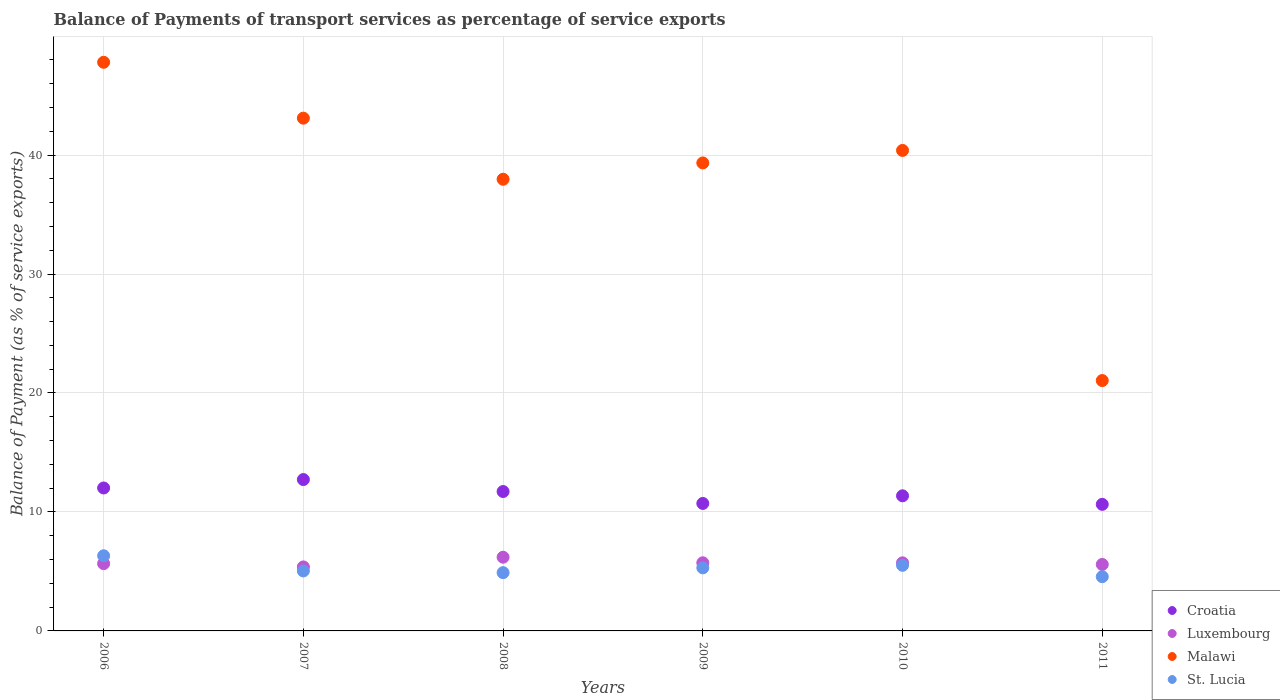How many different coloured dotlines are there?
Your response must be concise. 4. What is the balance of payments of transport services in Malawi in 2008?
Make the answer very short. 37.96. Across all years, what is the maximum balance of payments of transport services in St. Lucia?
Offer a very short reply. 6.32. Across all years, what is the minimum balance of payments of transport services in Luxembourg?
Make the answer very short. 5.38. What is the total balance of payments of transport services in Luxembourg in the graph?
Offer a terse response. 34.27. What is the difference between the balance of payments of transport services in St. Lucia in 2007 and that in 2008?
Provide a short and direct response. 0.14. What is the difference between the balance of payments of transport services in Malawi in 2011 and the balance of payments of transport services in Luxembourg in 2010?
Provide a succinct answer. 15.32. What is the average balance of payments of transport services in Luxembourg per year?
Your answer should be compact. 5.71. In the year 2011, what is the difference between the balance of payments of transport services in Croatia and balance of payments of transport services in Luxembourg?
Your response must be concise. 5.05. In how many years, is the balance of payments of transport services in Luxembourg greater than 46 %?
Your answer should be compact. 0. What is the ratio of the balance of payments of transport services in Luxembourg in 2008 to that in 2010?
Provide a succinct answer. 1.08. What is the difference between the highest and the second highest balance of payments of transport services in St. Lucia?
Give a very brief answer. 0.8. What is the difference between the highest and the lowest balance of payments of transport services in Malawi?
Your answer should be compact. 26.75. Is it the case that in every year, the sum of the balance of payments of transport services in Malawi and balance of payments of transport services in Croatia  is greater than the sum of balance of payments of transport services in St. Lucia and balance of payments of transport services in Luxembourg?
Keep it short and to the point. Yes. Is it the case that in every year, the sum of the balance of payments of transport services in St. Lucia and balance of payments of transport services in Luxembourg  is greater than the balance of payments of transport services in Malawi?
Provide a succinct answer. No. Is the balance of payments of transport services in Croatia strictly greater than the balance of payments of transport services in Malawi over the years?
Your response must be concise. No. How many years are there in the graph?
Offer a terse response. 6. What is the difference between two consecutive major ticks on the Y-axis?
Your answer should be compact. 10. Does the graph contain grids?
Offer a very short reply. Yes. Where does the legend appear in the graph?
Your answer should be very brief. Bottom right. What is the title of the graph?
Make the answer very short. Balance of Payments of transport services as percentage of service exports. What is the label or title of the X-axis?
Ensure brevity in your answer.  Years. What is the label or title of the Y-axis?
Your response must be concise. Balance of Payment (as % of service exports). What is the Balance of Payment (as % of service exports) of Croatia in 2006?
Offer a terse response. 12.01. What is the Balance of Payment (as % of service exports) of Luxembourg in 2006?
Your response must be concise. 5.66. What is the Balance of Payment (as % of service exports) of Malawi in 2006?
Your answer should be very brief. 47.8. What is the Balance of Payment (as % of service exports) of St. Lucia in 2006?
Provide a succinct answer. 6.32. What is the Balance of Payment (as % of service exports) in Croatia in 2007?
Make the answer very short. 12.72. What is the Balance of Payment (as % of service exports) of Luxembourg in 2007?
Keep it short and to the point. 5.38. What is the Balance of Payment (as % of service exports) in Malawi in 2007?
Ensure brevity in your answer.  43.1. What is the Balance of Payment (as % of service exports) of St. Lucia in 2007?
Your answer should be very brief. 5.04. What is the Balance of Payment (as % of service exports) in Croatia in 2008?
Your answer should be compact. 11.72. What is the Balance of Payment (as % of service exports) of Luxembourg in 2008?
Provide a short and direct response. 6.2. What is the Balance of Payment (as % of service exports) in Malawi in 2008?
Offer a terse response. 37.96. What is the Balance of Payment (as % of service exports) in St. Lucia in 2008?
Keep it short and to the point. 4.9. What is the Balance of Payment (as % of service exports) in Croatia in 2009?
Make the answer very short. 10.71. What is the Balance of Payment (as % of service exports) in Luxembourg in 2009?
Offer a very short reply. 5.73. What is the Balance of Payment (as % of service exports) in Malawi in 2009?
Provide a succinct answer. 39.33. What is the Balance of Payment (as % of service exports) of St. Lucia in 2009?
Offer a very short reply. 5.3. What is the Balance of Payment (as % of service exports) of Croatia in 2010?
Your response must be concise. 11.36. What is the Balance of Payment (as % of service exports) of Luxembourg in 2010?
Offer a very short reply. 5.72. What is the Balance of Payment (as % of service exports) in Malawi in 2010?
Provide a short and direct response. 40.39. What is the Balance of Payment (as % of service exports) in St. Lucia in 2010?
Provide a short and direct response. 5.51. What is the Balance of Payment (as % of service exports) in Croatia in 2011?
Your answer should be compact. 10.64. What is the Balance of Payment (as % of service exports) in Luxembourg in 2011?
Offer a very short reply. 5.59. What is the Balance of Payment (as % of service exports) in Malawi in 2011?
Your response must be concise. 21.05. What is the Balance of Payment (as % of service exports) of St. Lucia in 2011?
Provide a succinct answer. 4.56. Across all years, what is the maximum Balance of Payment (as % of service exports) of Croatia?
Offer a terse response. 12.72. Across all years, what is the maximum Balance of Payment (as % of service exports) of Luxembourg?
Your answer should be very brief. 6.2. Across all years, what is the maximum Balance of Payment (as % of service exports) in Malawi?
Your answer should be compact. 47.8. Across all years, what is the maximum Balance of Payment (as % of service exports) in St. Lucia?
Your answer should be very brief. 6.32. Across all years, what is the minimum Balance of Payment (as % of service exports) of Croatia?
Ensure brevity in your answer.  10.64. Across all years, what is the minimum Balance of Payment (as % of service exports) of Luxembourg?
Ensure brevity in your answer.  5.38. Across all years, what is the minimum Balance of Payment (as % of service exports) of Malawi?
Provide a succinct answer. 21.05. Across all years, what is the minimum Balance of Payment (as % of service exports) of St. Lucia?
Keep it short and to the point. 4.56. What is the total Balance of Payment (as % of service exports) of Croatia in the graph?
Your response must be concise. 69.16. What is the total Balance of Payment (as % of service exports) in Luxembourg in the graph?
Make the answer very short. 34.27. What is the total Balance of Payment (as % of service exports) of Malawi in the graph?
Ensure brevity in your answer.  229.63. What is the total Balance of Payment (as % of service exports) in St. Lucia in the graph?
Make the answer very short. 31.63. What is the difference between the Balance of Payment (as % of service exports) in Croatia in 2006 and that in 2007?
Give a very brief answer. -0.71. What is the difference between the Balance of Payment (as % of service exports) of Luxembourg in 2006 and that in 2007?
Your answer should be compact. 0.28. What is the difference between the Balance of Payment (as % of service exports) in Malawi in 2006 and that in 2007?
Your answer should be very brief. 4.7. What is the difference between the Balance of Payment (as % of service exports) of St. Lucia in 2006 and that in 2007?
Your answer should be compact. 1.28. What is the difference between the Balance of Payment (as % of service exports) in Croatia in 2006 and that in 2008?
Keep it short and to the point. 0.3. What is the difference between the Balance of Payment (as % of service exports) of Luxembourg in 2006 and that in 2008?
Offer a terse response. -0.54. What is the difference between the Balance of Payment (as % of service exports) in Malawi in 2006 and that in 2008?
Your answer should be compact. 9.83. What is the difference between the Balance of Payment (as % of service exports) in St. Lucia in 2006 and that in 2008?
Make the answer very short. 1.42. What is the difference between the Balance of Payment (as % of service exports) in Croatia in 2006 and that in 2009?
Keep it short and to the point. 1.3. What is the difference between the Balance of Payment (as % of service exports) in Luxembourg in 2006 and that in 2009?
Make the answer very short. -0.07. What is the difference between the Balance of Payment (as % of service exports) of Malawi in 2006 and that in 2009?
Offer a very short reply. 8.46. What is the difference between the Balance of Payment (as % of service exports) in St. Lucia in 2006 and that in 2009?
Your answer should be compact. 1.02. What is the difference between the Balance of Payment (as % of service exports) in Croatia in 2006 and that in 2010?
Provide a succinct answer. 0.66. What is the difference between the Balance of Payment (as % of service exports) of Luxembourg in 2006 and that in 2010?
Your response must be concise. -0.07. What is the difference between the Balance of Payment (as % of service exports) in Malawi in 2006 and that in 2010?
Provide a short and direct response. 7.41. What is the difference between the Balance of Payment (as % of service exports) in St. Lucia in 2006 and that in 2010?
Make the answer very short. 0.8. What is the difference between the Balance of Payment (as % of service exports) in Croatia in 2006 and that in 2011?
Your answer should be very brief. 1.38. What is the difference between the Balance of Payment (as % of service exports) in Luxembourg in 2006 and that in 2011?
Make the answer very short. 0.07. What is the difference between the Balance of Payment (as % of service exports) of Malawi in 2006 and that in 2011?
Provide a succinct answer. 26.75. What is the difference between the Balance of Payment (as % of service exports) in St. Lucia in 2006 and that in 2011?
Offer a terse response. 1.76. What is the difference between the Balance of Payment (as % of service exports) in Croatia in 2007 and that in 2008?
Your response must be concise. 1.01. What is the difference between the Balance of Payment (as % of service exports) of Luxembourg in 2007 and that in 2008?
Your answer should be very brief. -0.82. What is the difference between the Balance of Payment (as % of service exports) in Malawi in 2007 and that in 2008?
Ensure brevity in your answer.  5.14. What is the difference between the Balance of Payment (as % of service exports) in St. Lucia in 2007 and that in 2008?
Offer a terse response. 0.14. What is the difference between the Balance of Payment (as % of service exports) of Croatia in 2007 and that in 2009?
Give a very brief answer. 2.01. What is the difference between the Balance of Payment (as % of service exports) of Luxembourg in 2007 and that in 2009?
Make the answer very short. -0.35. What is the difference between the Balance of Payment (as % of service exports) in Malawi in 2007 and that in 2009?
Your answer should be compact. 3.76. What is the difference between the Balance of Payment (as % of service exports) in St. Lucia in 2007 and that in 2009?
Ensure brevity in your answer.  -0.26. What is the difference between the Balance of Payment (as % of service exports) in Croatia in 2007 and that in 2010?
Provide a succinct answer. 1.37. What is the difference between the Balance of Payment (as % of service exports) in Luxembourg in 2007 and that in 2010?
Offer a very short reply. -0.34. What is the difference between the Balance of Payment (as % of service exports) of Malawi in 2007 and that in 2010?
Offer a very short reply. 2.71. What is the difference between the Balance of Payment (as % of service exports) in St. Lucia in 2007 and that in 2010?
Give a very brief answer. -0.47. What is the difference between the Balance of Payment (as % of service exports) of Croatia in 2007 and that in 2011?
Give a very brief answer. 2.08. What is the difference between the Balance of Payment (as % of service exports) of Luxembourg in 2007 and that in 2011?
Your answer should be very brief. -0.21. What is the difference between the Balance of Payment (as % of service exports) of Malawi in 2007 and that in 2011?
Provide a succinct answer. 22.05. What is the difference between the Balance of Payment (as % of service exports) in St. Lucia in 2007 and that in 2011?
Keep it short and to the point. 0.48. What is the difference between the Balance of Payment (as % of service exports) of Croatia in 2008 and that in 2009?
Ensure brevity in your answer.  1. What is the difference between the Balance of Payment (as % of service exports) in Luxembourg in 2008 and that in 2009?
Give a very brief answer. 0.47. What is the difference between the Balance of Payment (as % of service exports) of Malawi in 2008 and that in 2009?
Your answer should be very brief. -1.37. What is the difference between the Balance of Payment (as % of service exports) of St. Lucia in 2008 and that in 2009?
Make the answer very short. -0.4. What is the difference between the Balance of Payment (as % of service exports) in Croatia in 2008 and that in 2010?
Provide a succinct answer. 0.36. What is the difference between the Balance of Payment (as % of service exports) of Luxembourg in 2008 and that in 2010?
Offer a very short reply. 0.47. What is the difference between the Balance of Payment (as % of service exports) of Malawi in 2008 and that in 2010?
Provide a short and direct response. -2.42. What is the difference between the Balance of Payment (as % of service exports) of St. Lucia in 2008 and that in 2010?
Your answer should be very brief. -0.61. What is the difference between the Balance of Payment (as % of service exports) of Croatia in 2008 and that in 2011?
Provide a succinct answer. 1.08. What is the difference between the Balance of Payment (as % of service exports) in Luxembourg in 2008 and that in 2011?
Your answer should be compact. 0.61. What is the difference between the Balance of Payment (as % of service exports) in Malawi in 2008 and that in 2011?
Your answer should be very brief. 16.92. What is the difference between the Balance of Payment (as % of service exports) of St. Lucia in 2008 and that in 2011?
Your response must be concise. 0.34. What is the difference between the Balance of Payment (as % of service exports) in Croatia in 2009 and that in 2010?
Offer a very short reply. -0.64. What is the difference between the Balance of Payment (as % of service exports) in Luxembourg in 2009 and that in 2010?
Ensure brevity in your answer.  0. What is the difference between the Balance of Payment (as % of service exports) in Malawi in 2009 and that in 2010?
Offer a terse response. -1.05. What is the difference between the Balance of Payment (as % of service exports) in St. Lucia in 2009 and that in 2010?
Your answer should be very brief. -0.21. What is the difference between the Balance of Payment (as % of service exports) of Croatia in 2009 and that in 2011?
Provide a succinct answer. 0.08. What is the difference between the Balance of Payment (as % of service exports) of Luxembourg in 2009 and that in 2011?
Your answer should be very brief. 0.14. What is the difference between the Balance of Payment (as % of service exports) of Malawi in 2009 and that in 2011?
Provide a short and direct response. 18.29. What is the difference between the Balance of Payment (as % of service exports) of St. Lucia in 2009 and that in 2011?
Provide a short and direct response. 0.74. What is the difference between the Balance of Payment (as % of service exports) in Croatia in 2010 and that in 2011?
Offer a very short reply. 0.72. What is the difference between the Balance of Payment (as % of service exports) of Luxembourg in 2010 and that in 2011?
Keep it short and to the point. 0.13. What is the difference between the Balance of Payment (as % of service exports) in Malawi in 2010 and that in 2011?
Offer a terse response. 19.34. What is the difference between the Balance of Payment (as % of service exports) in St. Lucia in 2010 and that in 2011?
Your answer should be compact. 0.95. What is the difference between the Balance of Payment (as % of service exports) in Croatia in 2006 and the Balance of Payment (as % of service exports) in Luxembourg in 2007?
Keep it short and to the point. 6.64. What is the difference between the Balance of Payment (as % of service exports) in Croatia in 2006 and the Balance of Payment (as % of service exports) in Malawi in 2007?
Provide a succinct answer. -31.08. What is the difference between the Balance of Payment (as % of service exports) in Croatia in 2006 and the Balance of Payment (as % of service exports) in St. Lucia in 2007?
Your answer should be compact. 6.97. What is the difference between the Balance of Payment (as % of service exports) in Luxembourg in 2006 and the Balance of Payment (as % of service exports) in Malawi in 2007?
Your response must be concise. -37.44. What is the difference between the Balance of Payment (as % of service exports) of Luxembourg in 2006 and the Balance of Payment (as % of service exports) of St. Lucia in 2007?
Ensure brevity in your answer.  0.61. What is the difference between the Balance of Payment (as % of service exports) of Malawi in 2006 and the Balance of Payment (as % of service exports) of St. Lucia in 2007?
Your response must be concise. 42.75. What is the difference between the Balance of Payment (as % of service exports) in Croatia in 2006 and the Balance of Payment (as % of service exports) in Luxembourg in 2008?
Your answer should be very brief. 5.82. What is the difference between the Balance of Payment (as % of service exports) in Croatia in 2006 and the Balance of Payment (as % of service exports) in Malawi in 2008?
Your response must be concise. -25.95. What is the difference between the Balance of Payment (as % of service exports) of Croatia in 2006 and the Balance of Payment (as % of service exports) of St. Lucia in 2008?
Keep it short and to the point. 7.12. What is the difference between the Balance of Payment (as % of service exports) of Luxembourg in 2006 and the Balance of Payment (as % of service exports) of Malawi in 2008?
Give a very brief answer. -32.31. What is the difference between the Balance of Payment (as % of service exports) of Luxembourg in 2006 and the Balance of Payment (as % of service exports) of St. Lucia in 2008?
Provide a short and direct response. 0.76. What is the difference between the Balance of Payment (as % of service exports) in Malawi in 2006 and the Balance of Payment (as % of service exports) in St. Lucia in 2008?
Make the answer very short. 42.9. What is the difference between the Balance of Payment (as % of service exports) in Croatia in 2006 and the Balance of Payment (as % of service exports) in Luxembourg in 2009?
Ensure brevity in your answer.  6.29. What is the difference between the Balance of Payment (as % of service exports) of Croatia in 2006 and the Balance of Payment (as % of service exports) of Malawi in 2009?
Offer a terse response. -27.32. What is the difference between the Balance of Payment (as % of service exports) in Croatia in 2006 and the Balance of Payment (as % of service exports) in St. Lucia in 2009?
Your answer should be very brief. 6.71. What is the difference between the Balance of Payment (as % of service exports) in Luxembourg in 2006 and the Balance of Payment (as % of service exports) in Malawi in 2009?
Provide a succinct answer. -33.68. What is the difference between the Balance of Payment (as % of service exports) in Luxembourg in 2006 and the Balance of Payment (as % of service exports) in St. Lucia in 2009?
Your answer should be compact. 0.35. What is the difference between the Balance of Payment (as % of service exports) of Malawi in 2006 and the Balance of Payment (as % of service exports) of St. Lucia in 2009?
Provide a succinct answer. 42.49. What is the difference between the Balance of Payment (as % of service exports) of Croatia in 2006 and the Balance of Payment (as % of service exports) of Luxembourg in 2010?
Offer a terse response. 6.29. What is the difference between the Balance of Payment (as % of service exports) of Croatia in 2006 and the Balance of Payment (as % of service exports) of Malawi in 2010?
Provide a succinct answer. -28.37. What is the difference between the Balance of Payment (as % of service exports) of Croatia in 2006 and the Balance of Payment (as % of service exports) of St. Lucia in 2010?
Offer a very short reply. 6.5. What is the difference between the Balance of Payment (as % of service exports) of Luxembourg in 2006 and the Balance of Payment (as % of service exports) of Malawi in 2010?
Offer a very short reply. -34.73. What is the difference between the Balance of Payment (as % of service exports) in Luxembourg in 2006 and the Balance of Payment (as % of service exports) in St. Lucia in 2010?
Your answer should be compact. 0.14. What is the difference between the Balance of Payment (as % of service exports) of Malawi in 2006 and the Balance of Payment (as % of service exports) of St. Lucia in 2010?
Make the answer very short. 42.28. What is the difference between the Balance of Payment (as % of service exports) in Croatia in 2006 and the Balance of Payment (as % of service exports) in Luxembourg in 2011?
Provide a succinct answer. 6.43. What is the difference between the Balance of Payment (as % of service exports) in Croatia in 2006 and the Balance of Payment (as % of service exports) in Malawi in 2011?
Give a very brief answer. -9.03. What is the difference between the Balance of Payment (as % of service exports) of Croatia in 2006 and the Balance of Payment (as % of service exports) of St. Lucia in 2011?
Keep it short and to the point. 7.45. What is the difference between the Balance of Payment (as % of service exports) of Luxembourg in 2006 and the Balance of Payment (as % of service exports) of Malawi in 2011?
Your answer should be compact. -15.39. What is the difference between the Balance of Payment (as % of service exports) of Luxembourg in 2006 and the Balance of Payment (as % of service exports) of St. Lucia in 2011?
Your answer should be compact. 1.1. What is the difference between the Balance of Payment (as % of service exports) in Malawi in 2006 and the Balance of Payment (as % of service exports) in St. Lucia in 2011?
Your response must be concise. 43.23. What is the difference between the Balance of Payment (as % of service exports) in Croatia in 2007 and the Balance of Payment (as % of service exports) in Luxembourg in 2008?
Provide a short and direct response. 6.53. What is the difference between the Balance of Payment (as % of service exports) in Croatia in 2007 and the Balance of Payment (as % of service exports) in Malawi in 2008?
Keep it short and to the point. -25.24. What is the difference between the Balance of Payment (as % of service exports) of Croatia in 2007 and the Balance of Payment (as % of service exports) of St. Lucia in 2008?
Ensure brevity in your answer.  7.82. What is the difference between the Balance of Payment (as % of service exports) in Luxembourg in 2007 and the Balance of Payment (as % of service exports) in Malawi in 2008?
Your answer should be compact. -32.58. What is the difference between the Balance of Payment (as % of service exports) of Luxembourg in 2007 and the Balance of Payment (as % of service exports) of St. Lucia in 2008?
Keep it short and to the point. 0.48. What is the difference between the Balance of Payment (as % of service exports) in Malawi in 2007 and the Balance of Payment (as % of service exports) in St. Lucia in 2008?
Give a very brief answer. 38.2. What is the difference between the Balance of Payment (as % of service exports) in Croatia in 2007 and the Balance of Payment (as % of service exports) in Luxembourg in 2009?
Give a very brief answer. 7. What is the difference between the Balance of Payment (as % of service exports) of Croatia in 2007 and the Balance of Payment (as % of service exports) of Malawi in 2009?
Provide a succinct answer. -26.61. What is the difference between the Balance of Payment (as % of service exports) in Croatia in 2007 and the Balance of Payment (as % of service exports) in St. Lucia in 2009?
Offer a very short reply. 7.42. What is the difference between the Balance of Payment (as % of service exports) of Luxembourg in 2007 and the Balance of Payment (as % of service exports) of Malawi in 2009?
Your answer should be very brief. -33.96. What is the difference between the Balance of Payment (as % of service exports) in Luxembourg in 2007 and the Balance of Payment (as % of service exports) in St. Lucia in 2009?
Provide a succinct answer. 0.08. What is the difference between the Balance of Payment (as % of service exports) in Malawi in 2007 and the Balance of Payment (as % of service exports) in St. Lucia in 2009?
Give a very brief answer. 37.8. What is the difference between the Balance of Payment (as % of service exports) in Croatia in 2007 and the Balance of Payment (as % of service exports) in Luxembourg in 2010?
Provide a succinct answer. 7. What is the difference between the Balance of Payment (as % of service exports) in Croatia in 2007 and the Balance of Payment (as % of service exports) in Malawi in 2010?
Provide a short and direct response. -27.67. What is the difference between the Balance of Payment (as % of service exports) of Croatia in 2007 and the Balance of Payment (as % of service exports) of St. Lucia in 2010?
Make the answer very short. 7.21. What is the difference between the Balance of Payment (as % of service exports) in Luxembourg in 2007 and the Balance of Payment (as % of service exports) in Malawi in 2010?
Offer a very short reply. -35.01. What is the difference between the Balance of Payment (as % of service exports) of Luxembourg in 2007 and the Balance of Payment (as % of service exports) of St. Lucia in 2010?
Offer a terse response. -0.13. What is the difference between the Balance of Payment (as % of service exports) of Malawi in 2007 and the Balance of Payment (as % of service exports) of St. Lucia in 2010?
Your response must be concise. 37.59. What is the difference between the Balance of Payment (as % of service exports) in Croatia in 2007 and the Balance of Payment (as % of service exports) in Luxembourg in 2011?
Give a very brief answer. 7.13. What is the difference between the Balance of Payment (as % of service exports) of Croatia in 2007 and the Balance of Payment (as % of service exports) of Malawi in 2011?
Give a very brief answer. -8.32. What is the difference between the Balance of Payment (as % of service exports) in Croatia in 2007 and the Balance of Payment (as % of service exports) in St. Lucia in 2011?
Offer a very short reply. 8.16. What is the difference between the Balance of Payment (as % of service exports) of Luxembourg in 2007 and the Balance of Payment (as % of service exports) of Malawi in 2011?
Keep it short and to the point. -15.67. What is the difference between the Balance of Payment (as % of service exports) of Luxembourg in 2007 and the Balance of Payment (as % of service exports) of St. Lucia in 2011?
Give a very brief answer. 0.82. What is the difference between the Balance of Payment (as % of service exports) of Malawi in 2007 and the Balance of Payment (as % of service exports) of St. Lucia in 2011?
Offer a terse response. 38.54. What is the difference between the Balance of Payment (as % of service exports) of Croatia in 2008 and the Balance of Payment (as % of service exports) of Luxembourg in 2009?
Ensure brevity in your answer.  5.99. What is the difference between the Balance of Payment (as % of service exports) in Croatia in 2008 and the Balance of Payment (as % of service exports) in Malawi in 2009?
Give a very brief answer. -27.62. What is the difference between the Balance of Payment (as % of service exports) of Croatia in 2008 and the Balance of Payment (as % of service exports) of St. Lucia in 2009?
Keep it short and to the point. 6.42. What is the difference between the Balance of Payment (as % of service exports) of Luxembourg in 2008 and the Balance of Payment (as % of service exports) of Malawi in 2009?
Offer a terse response. -33.14. What is the difference between the Balance of Payment (as % of service exports) of Luxembourg in 2008 and the Balance of Payment (as % of service exports) of St. Lucia in 2009?
Give a very brief answer. 0.89. What is the difference between the Balance of Payment (as % of service exports) in Malawi in 2008 and the Balance of Payment (as % of service exports) in St. Lucia in 2009?
Your answer should be compact. 32.66. What is the difference between the Balance of Payment (as % of service exports) of Croatia in 2008 and the Balance of Payment (as % of service exports) of Luxembourg in 2010?
Ensure brevity in your answer.  6. What is the difference between the Balance of Payment (as % of service exports) of Croatia in 2008 and the Balance of Payment (as % of service exports) of Malawi in 2010?
Make the answer very short. -28.67. What is the difference between the Balance of Payment (as % of service exports) in Croatia in 2008 and the Balance of Payment (as % of service exports) in St. Lucia in 2010?
Your response must be concise. 6.2. What is the difference between the Balance of Payment (as % of service exports) of Luxembourg in 2008 and the Balance of Payment (as % of service exports) of Malawi in 2010?
Your answer should be very brief. -34.19. What is the difference between the Balance of Payment (as % of service exports) of Luxembourg in 2008 and the Balance of Payment (as % of service exports) of St. Lucia in 2010?
Offer a terse response. 0.68. What is the difference between the Balance of Payment (as % of service exports) in Malawi in 2008 and the Balance of Payment (as % of service exports) in St. Lucia in 2010?
Provide a short and direct response. 32.45. What is the difference between the Balance of Payment (as % of service exports) of Croatia in 2008 and the Balance of Payment (as % of service exports) of Luxembourg in 2011?
Give a very brief answer. 6.13. What is the difference between the Balance of Payment (as % of service exports) of Croatia in 2008 and the Balance of Payment (as % of service exports) of Malawi in 2011?
Provide a short and direct response. -9.33. What is the difference between the Balance of Payment (as % of service exports) of Croatia in 2008 and the Balance of Payment (as % of service exports) of St. Lucia in 2011?
Your answer should be very brief. 7.16. What is the difference between the Balance of Payment (as % of service exports) of Luxembourg in 2008 and the Balance of Payment (as % of service exports) of Malawi in 2011?
Offer a very short reply. -14.85. What is the difference between the Balance of Payment (as % of service exports) of Luxembourg in 2008 and the Balance of Payment (as % of service exports) of St. Lucia in 2011?
Offer a very short reply. 1.64. What is the difference between the Balance of Payment (as % of service exports) in Malawi in 2008 and the Balance of Payment (as % of service exports) in St. Lucia in 2011?
Your answer should be compact. 33.4. What is the difference between the Balance of Payment (as % of service exports) in Croatia in 2009 and the Balance of Payment (as % of service exports) in Luxembourg in 2010?
Ensure brevity in your answer.  4.99. What is the difference between the Balance of Payment (as % of service exports) in Croatia in 2009 and the Balance of Payment (as % of service exports) in Malawi in 2010?
Provide a succinct answer. -29.67. What is the difference between the Balance of Payment (as % of service exports) in Croatia in 2009 and the Balance of Payment (as % of service exports) in St. Lucia in 2010?
Provide a succinct answer. 5.2. What is the difference between the Balance of Payment (as % of service exports) of Luxembourg in 2009 and the Balance of Payment (as % of service exports) of Malawi in 2010?
Make the answer very short. -34.66. What is the difference between the Balance of Payment (as % of service exports) of Luxembourg in 2009 and the Balance of Payment (as % of service exports) of St. Lucia in 2010?
Give a very brief answer. 0.21. What is the difference between the Balance of Payment (as % of service exports) of Malawi in 2009 and the Balance of Payment (as % of service exports) of St. Lucia in 2010?
Keep it short and to the point. 33.82. What is the difference between the Balance of Payment (as % of service exports) in Croatia in 2009 and the Balance of Payment (as % of service exports) in Luxembourg in 2011?
Provide a succinct answer. 5.13. What is the difference between the Balance of Payment (as % of service exports) of Croatia in 2009 and the Balance of Payment (as % of service exports) of Malawi in 2011?
Your response must be concise. -10.33. What is the difference between the Balance of Payment (as % of service exports) of Croatia in 2009 and the Balance of Payment (as % of service exports) of St. Lucia in 2011?
Keep it short and to the point. 6.15. What is the difference between the Balance of Payment (as % of service exports) of Luxembourg in 2009 and the Balance of Payment (as % of service exports) of Malawi in 2011?
Your answer should be very brief. -15.32. What is the difference between the Balance of Payment (as % of service exports) of Luxembourg in 2009 and the Balance of Payment (as % of service exports) of St. Lucia in 2011?
Keep it short and to the point. 1.17. What is the difference between the Balance of Payment (as % of service exports) in Malawi in 2009 and the Balance of Payment (as % of service exports) in St. Lucia in 2011?
Provide a short and direct response. 34.77. What is the difference between the Balance of Payment (as % of service exports) in Croatia in 2010 and the Balance of Payment (as % of service exports) in Luxembourg in 2011?
Keep it short and to the point. 5.77. What is the difference between the Balance of Payment (as % of service exports) of Croatia in 2010 and the Balance of Payment (as % of service exports) of Malawi in 2011?
Provide a succinct answer. -9.69. What is the difference between the Balance of Payment (as % of service exports) in Croatia in 2010 and the Balance of Payment (as % of service exports) in St. Lucia in 2011?
Provide a succinct answer. 6.8. What is the difference between the Balance of Payment (as % of service exports) in Luxembourg in 2010 and the Balance of Payment (as % of service exports) in Malawi in 2011?
Provide a succinct answer. -15.32. What is the difference between the Balance of Payment (as % of service exports) of Luxembourg in 2010 and the Balance of Payment (as % of service exports) of St. Lucia in 2011?
Keep it short and to the point. 1.16. What is the difference between the Balance of Payment (as % of service exports) in Malawi in 2010 and the Balance of Payment (as % of service exports) in St. Lucia in 2011?
Offer a terse response. 35.83. What is the average Balance of Payment (as % of service exports) of Croatia per year?
Offer a terse response. 11.53. What is the average Balance of Payment (as % of service exports) in Luxembourg per year?
Your response must be concise. 5.71. What is the average Balance of Payment (as % of service exports) of Malawi per year?
Your response must be concise. 38.27. What is the average Balance of Payment (as % of service exports) in St. Lucia per year?
Ensure brevity in your answer.  5.27. In the year 2006, what is the difference between the Balance of Payment (as % of service exports) of Croatia and Balance of Payment (as % of service exports) of Luxembourg?
Ensure brevity in your answer.  6.36. In the year 2006, what is the difference between the Balance of Payment (as % of service exports) of Croatia and Balance of Payment (as % of service exports) of Malawi?
Keep it short and to the point. -35.78. In the year 2006, what is the difference between the Balance of Payment (as % of service exports) in Croatia and Balance of Payment (as % of service exports) in St. Lucia?
Provide a short and direct response. 5.7. In the year 2006, what is the difference between the Balance of Payment (as % of service exports) of Luxembourg and Balance of Payment (as % of service exports) of Malawi?
Keep it short and to the point. -42.14. In the year 2006, what is the difference between the Balance of Payment (as % of service exports) in Luxembourg and Balance of Payment (as % of service exports) in St. Lucia?
Your answer should be compact. -0.66. In the year 2006, what is the difference between the Balance of Payment (as % of service exports) of Malawi and Balance of Payment (as % of service exports) of St. Lucia?
Offer a terse response. 41.48. In the year 2007, what is the difference between the Balance of Payment (as % of service exports) in Croatia and Balance of Payment (as % of service exports) in Luxembourg?
Ensure brevity in your answer.  7.34. In the year 2007, what is the difference between the Balance of Payment (as % of service exports) in Croatia and Balance of Payment (as % of service exports) in Malawi?
Your answer should be very brief. -30.38. In the year 2007, what is the difference between the Balance of Payment (as % of service exports) in Croatia and Balance of Payment (as % of service exports) in St. Lucia?
Give a very brief answer. 7.68. In the year 2007, what is the difference between the Balance of Payment (as % of service exports) in Luxembourg and Balance of Payment (as % of service exports) in Malawi?
Provide a succinct answer. -37.72. In the year 2007, what is the difference between the Balance of Payment (as % of service exports) of Luxembourg and Balance of Payment (as % of service exports) of St. Lucia?
Keep it short and to the point. 0.34. In the year 2007, what is the difference between the Balance of Payment (as % of service exports) of Malawi and Balance of Payment (as % of service exports) of St. Lucia?
Ensure brevity in your answer.  38.06. In the year 2008, what is the difference between the Balance of Payment (as % of service exports) in Croatia and Balance of Payment (as % of service exports) in Luxembourg?
Your response must be concise. 5.52. In the year 2008, what is the difference between the Balance of Payment (as % of service exports) of Croatia and Balance of Payment (as % of service exports) of Malawi?
Your answer should be very brief. -26.25. In the year 2008, what is the difference between the Balance of Payment (as % of service exports) of Croatia and Balance of Payment (as % of service exports) of St. Lucia?
Make the answer very short. 6.82. In the year 2008, what is the difference between the Balance of Payment (as % of service exports) of Luxembourg and Balance of Payment (as % of service exports) of Malawi?
Your answer should be compact. -31.77. In the year 2008, what is the difference between the Balance of Payment (as % of service exports) of Luxembourg and Balance of Payment (as % of service exports) of St. Lucia?
Your answer should be very brief. 1.3. In the year 2008, what is the difference between the Balance of Payment (as % of service exports) of Malawi and Balance of Payment (as % of service exports) of St. Lucia?
Keep it short and to the point. 33.07. In the year 2009, what is the difference between the Balance of Payment (as % of service exports) of Croatia and Balance of Payment (as % of service exports) of Luxembourg?
Your answer should be very brief. 4.99. In the year 2009, what is the difference between the Balance of Payment (as % of service exports) in Croatia and Balance of Payment (as % of service exports) in Malawi?
Your answer should be very brief. -28.62. In the year 2009, what is the difference between the Balance of Payment (as % of service exports) in Croatia and Balance of Payment (as % of service exports) in St. Lucia?
Offer a very short reply. 5.41. In the year 2009, what is the difference between the Balance of Payment (as % of service exports) of Luxembourg and Balance of Payment (as % of service exports) of Malawi?
Offer a terse response. -33.61. In the year 2009, what is the difference between the Balance of Payment (as % of service exports) of Luxembourg and Balance of Payment (as % of service exports) of St. Lucia?
Offer a very short reply. 0.42. In the year 2009, what is the difference between the Balance of Payment (as % of service exports) of Malawi and Balance of Payment (as % of service exports) of St. Lucia?
Your response must be concise. 34.03. In the year 2010, what is the difference between the Balance of Payment (as % of service exports) of Croatia and Balance of Payment (as % of service exports) of Luxembourg?
Ensure brevity in your answer.  5.63. In the year 2010, what is the difference between the Balance of Payment (as % of service exports) in Croatia and Balance of Payment (as % of service exports) in Malawi?
Your answer should be very brief. -29.03. In the year 2010, what is the difference between the Balance of Payment (as % of service exports) in Croatia and Balance of Payment (as % of service exports) in St. Lucia?
Your answer should be compact. 5.84. In the year 2010, what is the difference between the Balance of Payment (as % of service exports) of Luxembourg and Balance of Payment (as % of service exports) of Malawi?
Your answer should be very brief. -34.67. In the year 2010, what is the difference between the Balance of Payment (as % of service exports) of Luxembourg and Balance of Payment (as % of service exports) of St. Lucia?
Make the answer very short. 0.21. In the year 2010, what is the difference between the Balance of Payment (as % of service exports) of Malawi and Balance of Payment (as % of service exports) of St. Lucia?
Give a very brief answer. 34.87. In the year 2011, what is the difference between the Balance of Payment (as % of service exports) of Croatia and Balance of Payment (as % of service exports) of Luxembourg?
Provide a succinct answer. 5.05. In the year 2011, what is the difference between the Balance of Payment (as % of service exports) of Croatia and Balance of Payment (as % of service exports) of Malawi?
Provide a short and direct response. -10.41. In the year 2011, what is the difference between the Balance of Payment (as % of service exports) in Croatia and Balance of Payment (as % of service exports) in St. Lucia?
Offer a terse response. 6.08. In the year 2011, what is the difference between the Balance of Payment (as % of service exports) in Luxembourg and Balance of Payment (as % of service exports) in Malawi?
Provide a succinct answer. -15.46. In the year 2011, what is the difference between the Balance of Payment (as % of service exports) of Luxembourg and Balance of Payment (as % of service exports) of St. Lucia?
Offer a terse response. 1.03. In the year 2011, what is the difference between the Balance of Payment (as % of service exports) of Malawi and Balance of Payment (as % of service exports) of St. Lucia?
Your answer should be very brief. 16.48. What is the ratio of the Balance of Payment (as % of service exports) of Croatia in 2006 to that in 2007?
Offer a very short reply. 0.94. What is the ratio of the Balance of Payment (as % of service exports) in Luxembourg in 2006 to that in 2007?
Give a very brief answer. 1.05. What is the ratio of the Balance of Payment (as % of service exports) in Malawi in 2006 to that in 2007?
Keep it short and to the point. 1.11. What is the ratio of the Balance of Payment (as % of service exports) in St. Lucia in 2006 to that in 2007?
Your answer should be compact. 1.25. What is the ratio of the Balance of Payment (as % of service exports) of Croatia in 2006 to that in 2008?
Your answer should be very brief. 1.03. What is the ratio of the Balance of Payment (as % of service exports) of Luxembourg in 2006 to that in 2008?
Your response must be concise. 0.91. What is the ratio of the Balance of Payment (as % of service exports) in Malawi in 2006 to that in 2008?
Your answer should be compact. 1.26. What is the ratio of the Balance of Payment (as % of service exports) in St. Lucia in 2006 to that in 2008?
Your answer should be compact. 1.29. What is the ratio of the Balance of Payment (as % of service exports) of Croatia in 2006 to that in 2009?
Make the answer very short. 1.12. What is the ratio of the Balance of Payment (as % of service exports) of Malawi in 2006 to that in 2009?
Offer a very short reply. 1.22. What is the ratio of the Balance of Payment (as % of service exports) in St. Lucia in 2006 to that in 2009?
Your response must be concise. 1.19. What is the ratio of the Balance of Payment (as % of service exports) of Croatia in 2006 to that in 2010?
Your answer should be very brief. 1.06. What is the ratio of the Balance of Payment (as % of service exports) in Luxembourg in 2006 to that in 2010?
Your answer should be compact. 0.99. What is the ratio of the Balance of Payment (as % of service exports) of Malawi in 2006 to that in 2010?
Keep it short and to the point. 1.18. What is the ratio of the Balance of Payment (as % of service exports) in St. Lucia in 2006 to that in 2010?
Your response must be concise. 1.15. What is the ratio of the Balance of Payment (as % of service exports) of Croatia in 2006 to that in 2011?
Keep it short and to the point. 1.13. What is the ratio of the Balance of Payment (as % of service exports) in Luxembourg in 2006 to that in 2011?
Ensure brevity in your answer.  1.01. What is the ratio of the Balance of Payment (as % of service exports) in Malawi in 2006 to that in 2011?
Your answer should be very brief. 2.27. What is the ratio of the Balance of Payment (as % of service exports) of St. Lucia in 2006 to that in 2011?
Give a very brief answer. 1.39. What is the ratio of the Balance of Payment (as % of service exports) in Croatia in 2007 to that in 2008?
Offer a terse response. 1.09. What is the ratio of the Balance of Payment (as % of service exports) of Luxembourg in 2007 to that in 2008?
Keep it short and to the point. 0.87. What is the ratio of the Balance of Payment (as % of service exports) of Malawi in 2007 to that in 2008?
Provide a short and direct response. 1.14. What is the ratio of the Balance of Payment (as % of service exports) of St. Lucia in 2007 to that in 2008?
Offer a very short reply. 1.03. What is the ratio of the Balance of Payment (as % of service exports) in Croatia in 2007 to that in 2009?
Your answer should be very brief. 1.19. What is the ratio of the Balance of Payment (as % of service exports) in Luxembourg in 2007 to that in 2009?
Give a very brief answer. 0.94. What is the ratio of the Balance of Payment (as % of service exports) in Malawi in 2007 to that in 2009?
Your response must be concise. 1.1. What is the ratio of the Balance of Payment (as % of service exports) of St. Lucia in 2007 to that in 2009?
Your answer should be very brief. 0.95. What is the ratio of the Balance of Payment (as % of service exports) in Croatia in 2007 to that in 2010?
Make the answer very short. 1.12. What is the ratio of the Balance of Payment (as % of service exports) in Luxembourg in 2007 to that in 2010?
Your answer should be very brief. 0.94. What is the ratio of the Balance of Payment (as % of service exports) in Malawi in 2007 to that in 2010?
Your answer should be very brief. 1.07. What is the ratio of the Balance of Payment (as % of service exports) of St. Lucia in 2007 to that in 2010?
Offer a very short reply. 0.91. What is the ratio of the Balance of Payment (as % of service exports) in Croatia in 2007 to that in 2011?
Provide a succinct answer. 1.2. What is the ratio of the Balance of Payment (as % of service exports) in Luxembourg in 2007 to that in 2011?
Provide a succinct answer. 0.96. What is the ratio of the Balance of Payment (as % of service exports) of Malawi in 2007 to that in 2011?
Make the answer very short. 2.05. What is the ratio of the Balance of Payment (as % of service exports) of St. Lucia in 2007 to that in 2011?
Offer a very short reply. 1.11. What is the ratio of the Balance of Payment (as % of service exports) of Croatia in 2008 to that in 2009?
Provide a succinct answer. 1.09. What is the ratio of the Balance of Payment (as % of service exports) of Luxembourg in 2008 to that in 2009?
Offer a very short reply. 1.08. What is the ratio of the Balance of Payment (as % of service exports) of Malawi in 2008 to that in 2009?
Keep it short and to the point. 0.97. What is the ratio of the Balance of Payment (as % of service exports) in St. Lucia in 2008 to that in 2009?
Provide a short and direct response. 0.92. What is the ratio of the Balance of Payment (as % of service exports) in Croatia in 2008 to that in 2010?
Make the answer very short. 1.03. What is the ratio of the Balance of Payment (as % of service exports) in Luxembourg in 2008 to that in 2010?
Make the answer very short. 1.08. What is the ratio of the Balance of Payment (as % of service exports) in Malawi in 2008 to that in 2010?
Provide a short and direct response. 0.94. What is the ratio of the Balance of Payment (as % of service exports) in St. Lucia in 2008 to that in 2010?
Provide a short and direct response. 0.89. What is the ratio of the Balance of Payment (as % of service exports) of Croatia in 2008 to that in 2011?
Your answer should be compact. 1.1. What is the ratio of the Balance of Payment (as % of service exports) in Luxembourg in 2008 to that in 2011?
Your answer should be compact. 1.11. What is the ratio of the Balance of Payment (as % of service exports) in Malawi in 2008 to that in 2011?
Make the answer very short. 1.8. What is the ratio of the Balance of Payment (as % of service exports) of St. Lucia in 2008 to that in 2011?
Make the answer very short. 1.07. What is the ratio of the Balance of Payment (as % of service exports) of Croatia in 2009 to that in 2010?
Offer a very short reply. 0.94. What is the ratio of the Balance of Payment (as % of service exports) of Malawi in 2009 to that in 2010?
Offer a very short reply. 0.97. What is the ratio of the Balance of Payment (as % of service exports) in St. Lucia in 2009 to that in 2010?
Give a very brief answer. 0.96. What is the ratio of the Balance of Payment (as % of service exports) of Croatia in 2009 to that in 2011?
Offer a very short reply. 1.01. What is the ratio of the Balance of Payment (as % of service exports) of Luxembourg in 2009 to that in 2011?
Offer a terse response. 1.02. What is the ratio of the Balance of Payment (as % of service exports) of Malawi in 2009 to that in 2011?
Your response must be concise. 1.87. What is the ratio of the Balance of Payment (as % of service exports) in St. Lucia in 2009 to that in 2011?
Your response must be concise. 1.16. What is the ratio of the Balance of Payment (as % of service exports) of Croatia in 2010 to that in 2011?
Your answer should be very brief. 1.07. What is the ratio of the Balance of Payment (as % of service exports) in Luxembourg in 2010 to that in 2011?
Offer a terse response. 1.02. What is the ratio of the Balance of Payment (as % of service exports) of Malawi in 2010 to that in 2011?
Make the answer very short. 1.92. What is the ratio of the Balance of Payment (as % of service exports) of St. Lucia in 2010 to that in 2011?
Your answer should be very brief. 1.21. What is the difference between the highest and the second highest Balance of Payment (as % of service exports) of Croatia?
Provide a short and direct response. 0.71. What is the difference between the highest and the second highest Balance of Payment (as % of service exports) in Luxembourg?
Your answer should be compact. 0.47. What is the difference between the highest and the second highest Balance of Payment (as % of service exports) in Malawi?
Provide a short and direct response. 4.7. What is the difference between the highest and the second highest Balance of Payment (as % of service exports) in St. Lucia?
Make the answer very short. 0.8. What is the difference between the highest and the lowest Balance of Payment (as % of service exports) in Croatia?
Keep it short and to the point. 2.08. What is the difference between the highest and the lowest Balance of Payment (as % of service exports) of Luxembourg?
Provide a succinct answer. 0.82. What is the difference between the highest and the lowest Balance of Payment (as % of service exports) of Malawi?
Ensure brevity in your answer.  26.75. What is the difference between the highest and the lowest Balance of Payment (as % of service exports) of St. Lucia?
Offer a terse response. 1.76. 